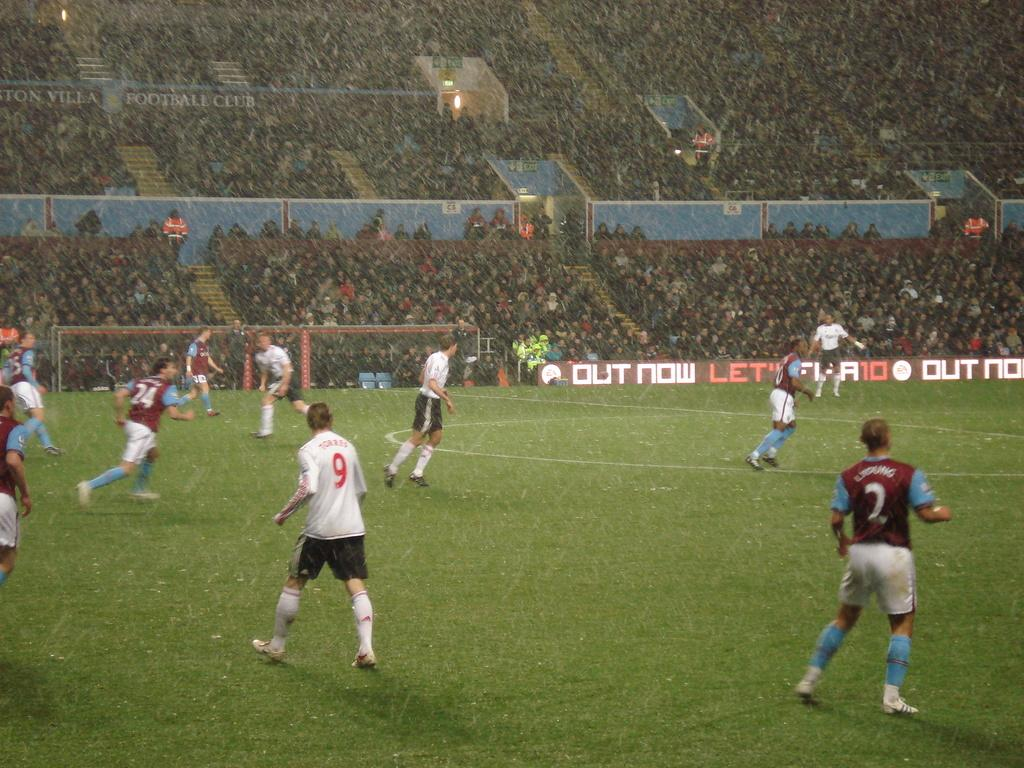<image>
Offer a succinct explanation of the picture presented. Soccer players playing in the rain as number 9 is looking on. 